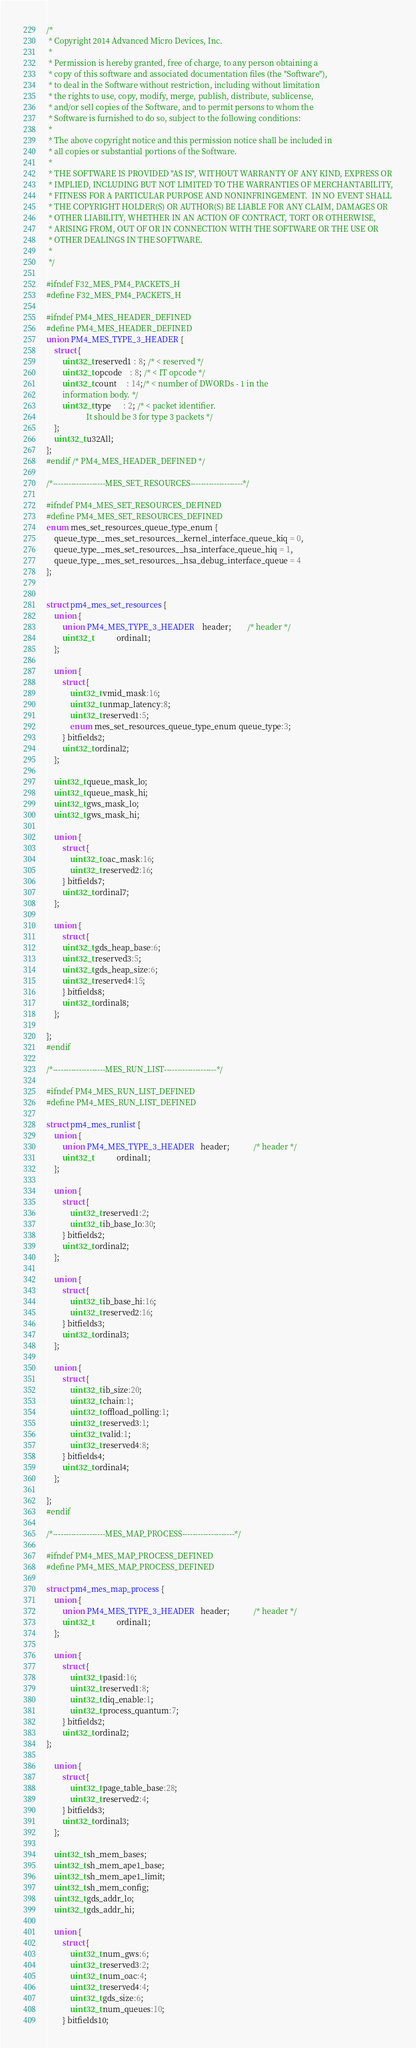<code> <loc_0><loc_0><loc_500><loc_500><_C_>/*
 * Copyright 2014 Advanced Micro Devices, Inc.
 *
 * Permission is hereby granted, free of charge, to any person obtaining a
 * copy of this software and associated documentation files (the "Software"),
 * to deal in the Software without restriction, including without limitation
 * the rights to use, copy, modify, merge, publish, distribute, sublicense,
 * and/or sell copies of the Software, and to permit persons to whom the
 * Software is furnished to do so, subject to the following conditions:
 *
 * The above copyright notice and this permission notice shall be included in
 * all copies or substantial portions of the Software.
 *
 * THE SOFTWARE IS PROVIDED "AS IS", WITHOUT WARRANTY OF ANY KIND, EXPRESS OR
 * IMPLIED, INCLUDING BUT NOT LIMITED TO THE WARRANTIES OF MERCHANTABILITY,
 * FITNESS FOR A PARTICULAR PURPOSE AND NONINFRINGEMENT.  IN NO EVENT SHALL
 * THE COPYRIGHT HOLDER(S) OR AUTHOR(S) BE LIABLE FOR ANY CLAIM, DAMAGES OR
 * OTHER LIABILITY, WHETHER IN AN ACTION OF CONTRACT, TORT OR OTHERWISE,
 * ARISING FROM, OUT OF OR IN CONNECTION WITH THE SOFTWARE OR THE USE OR
 * OTHER DEALINGS IN THE SOFTWARE.
 *
 */

#ifndef F32_MES_PM4_PACKETS_H
#define F32_MES_PM4_PACKETS_H

#ifndef PM4_MES_HEADER_DEFINED
#define PM4_MES_HEADER_DEFINED
union PM4_MES_TYPE_3_HEADER {
	struct {
		uint32_t reserved1 : 8; /* < reserved */
		uint32_t opcode    : 8; /* < IT opcode */
		uint32_t count     : 14;/* < number of DWORDs - 1 in the
		information body. */
		uint32_t type      : 2; /* < packet identifier.
					It should be 3 for type 3 packets */
	};
	uint32_t u32All;
};
#endif /* PM4_MES_HEADER_DEFINED */

/*--------------------MES_SET_RESOURCES--------------------*/

#ifndef PM4_MES_SET_RESOURCES_DEFINED
#define PM4_MES_SET_RESOURCES_DEFINED
enum mes_set_resources_queue_type_enum {
	queue_type__mes_set_resources__kernel_interface_queue_kiq = 0,
	queue_type__mes_set_resources__hsa_interface_queue_hiq = 1,
	queue_type__mes_set_resources__hsa_debug_interface_queue = 4
};


struct pm4_mes_set_resources {
	union {
		union PM4_MES_TYPE_3_HEADER	header;		/* header */
		uint32_t			ordinal1;
	};

	union {
		struct {
			uint32_t vmid_mask:16;
			uint32_t unmap_latency:8;
			uint32_t reserved1:5;
			enum mes_set_resources_queue_type_enum queue_type:3;
		} bitfields2;
		uint32_t ordinal2;
	};

	uint32_t queue_mask_lo;
	uint32_t queue_mask_hi;
	uint32_t gws_mask_lo;
	uint32_t gws_mask_hi;

	union {
		struct {
			uint32_t oac_mask:16;
			uint32_t reserved2:16;
		} bitfields7;
		uint32_t ordinal7;
	};

	union {
		struct {
		uint32_t gds_heap_base:6;
		uint32_t reserved3:5;
		uint32_t gds_heap_size:6;
		uint32_t reserved4:15;
		} bitfields8;
		uint32_t ordinal8;
	};

};
#endif

/*--------------------MES_RUN_LIST--------------------*/

#ifndef PM4_MES_RUN_LIST_DEFINED
#define PM4_MES_RUN_LIST_DEFINED

struct pm4_mes_runlist {
	union {
	    union PM4_MES_TYPE_3_HEADER   header;            /* header */
	    uint32_t            ordinal1;
	};

	union {
		struct {
			uint32_t reserved1:2;
			uint32_t ib_base_lo:30;
		} bitfields2;
		uint32_t ordinal2;
	};

	union {
		struct {
			uint32_t ib_base_hi:16;
			uint32_t reserved2:16;
		} bitfields3;
		uint32_t ordinal3;
	};

	union {
		struct {
			uint32_t ib_size:20;
			uint32_t chain:1;
			uint32_t offload_polling:1;
			uint32_t reserved3:1;
			uint32_t valid:1;
			uint32_t reserved4:8;
		} bitfields4;
		uint32_t ordinal4;
	};

};
#endif

/*--------------------MES_MAP_PROCESS--------------------*/

#ifndef PM4_MES_MAP_PROCESS_DEFINED
#define PM4_MES_MAP_PROCESS_DEFINED

struct pm4_mes_map_process {
	union {
		union PM4_MES_TYPE_3_HEADER   header;            /* header */
		uint32_t            ordinal1;
	};

	union {
		struct {
			uint32_t pasid:16;
			uint32_t reserved1:8;
			uint32_t diq_enable:1;
			uint32_t process_quantum:7;
		} bitfields2;
		uint32_t ordinal2;
};

	union {
		struct {
			uint32_t page_table_base:28;
			uint32_t reserved2:4;
		} bitfields3;
		uint32_t ordinal3;
	};

	uint32_t sh_mem_bases;
	uint32_t sh_mem_ape1_base;
	uint32_t sh_mem_ape1_limit;
	uint32_t sh_mem_config;
	uint32_t gds_addr_lo;
	uint32_t gds_addr_hi;

	union {
		struct {
			uint32_t num_gws:6;
			uint32_t reserved3:2;
			uint32_t num_oac:4;
			uint32_t reserved4:4;
			uint32_t gds_size:6;
			uint32_t num_queues:10;
		} bitfields10;</code> 